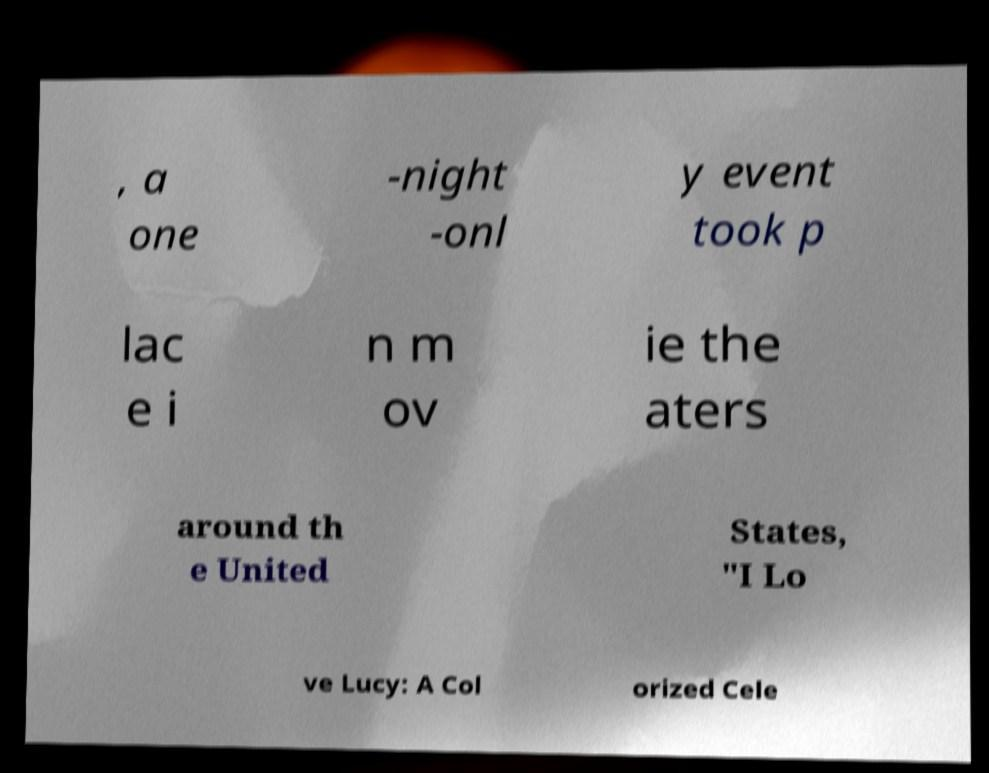I need the written content from this picture converted into text. Can you do that? , a one -night -onl y event took p lac e i n m ov ie the aters around th e United States, "I Lo ve Lucy: A Col orized Cele 